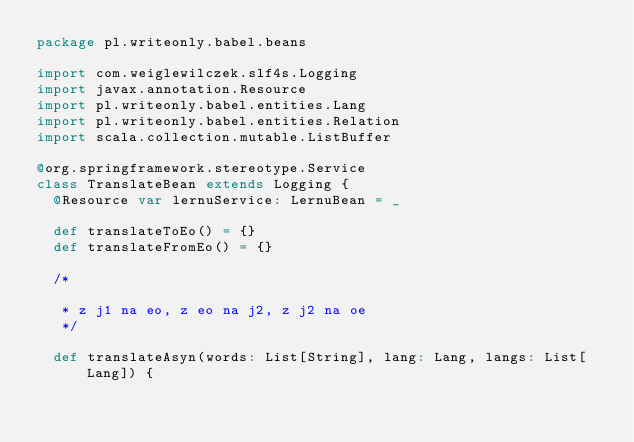<code> <loc_0><loc_0><loc_500><loc_500><_Scala_>package pl.writeonly.babel.beans

import com.weiglewilczek.slf4s.Logging
import javax.annotation.Resource
import pl.writeonly.babel.entities.Lang
import pl.writeonly.babel.entities.Relation
import scala.collection.mutable.ListBuffer

@org.springframework.stereotype.Service
class TranslateBean extends Logging {
  @Resource var lernuService: LernuBean = _

  def translateToEo() = {}
  def translateFromEo() = {}

  /*

   * z j1 na eo, z eo na j2, z j2 na oe
   */

  def translateAsyn(words: List[String], lang: Lang, langs: List[Lang]) {</code> 